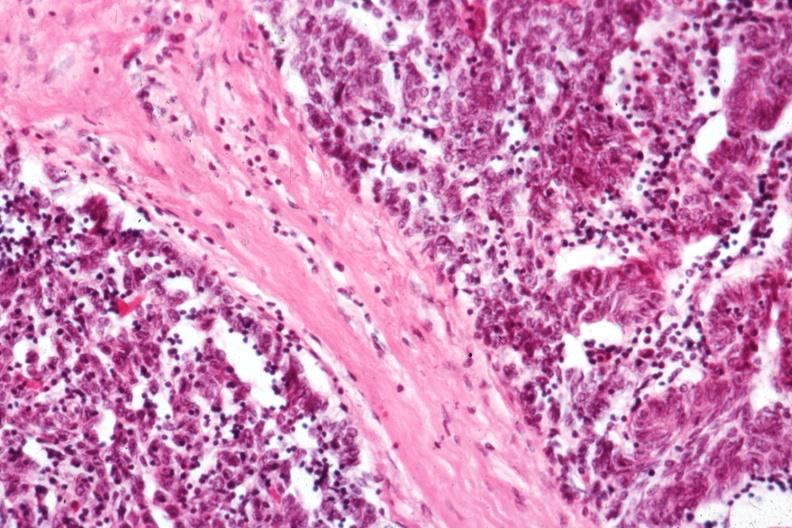s infarction secondary to shock present?
Answer the question using a single word or phrase. No 